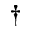<formula> <loc_0><loc_0><loc_500><loc_500>^ { \dagger }</formula> 